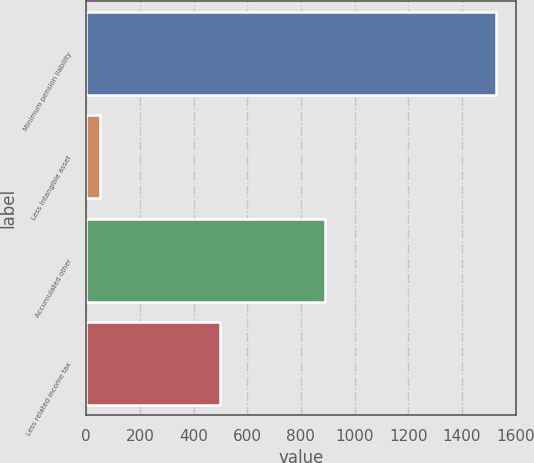<chart> <loc_0><loc_0><loc_500><loc_500><bar_chart><fcel>Minimum pension liability<fcel>Less intangible asset<fcel>Accumulated other<fcel>Less related income tax<nl><fcel>1525.15<fcel>50<fcel>888.2<fcel>498.3<nl></chart> 